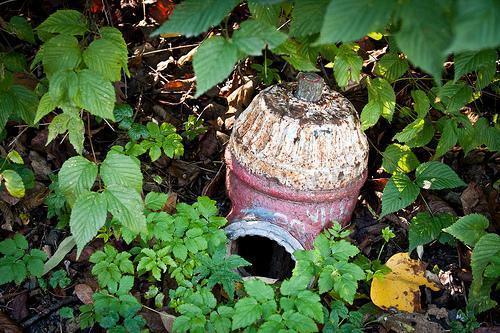How many hydrants are visible?
Give a very brief answer. 1. How many leaves are on the one plant?
Give a very brief answer. 4. 